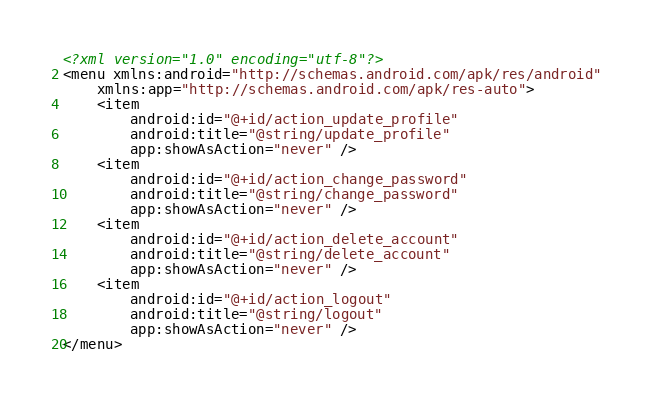Convert code to text. <code><loc_0><loc_0><loc_500><loc_500><_XML_><?xml version="1.0" encoding="utf-8"?>
<menu xmlns:android="http://schemas.android.com/apk/res/android"
    xmlns:app="http://schemas.android.com/apk/res-auto">
    <item
        android:id="@+id/action_update_profile"
        android:title="@string/update_profile"
        app:showAsAction="never" />
    <item
        android:id="@+id/action_change_password"
        android:title="@string/change_password"
        app:showAsAction="never" />
    <item
        android:id="@+id/action_delete_account"
        android:title="@string/delete_account"
        app:showAsAction="never" />
    <item
        android:id="@+id/action_logout"
        android:title="@string/logout"
        app:showAsAction="never" />
</menu></code> 